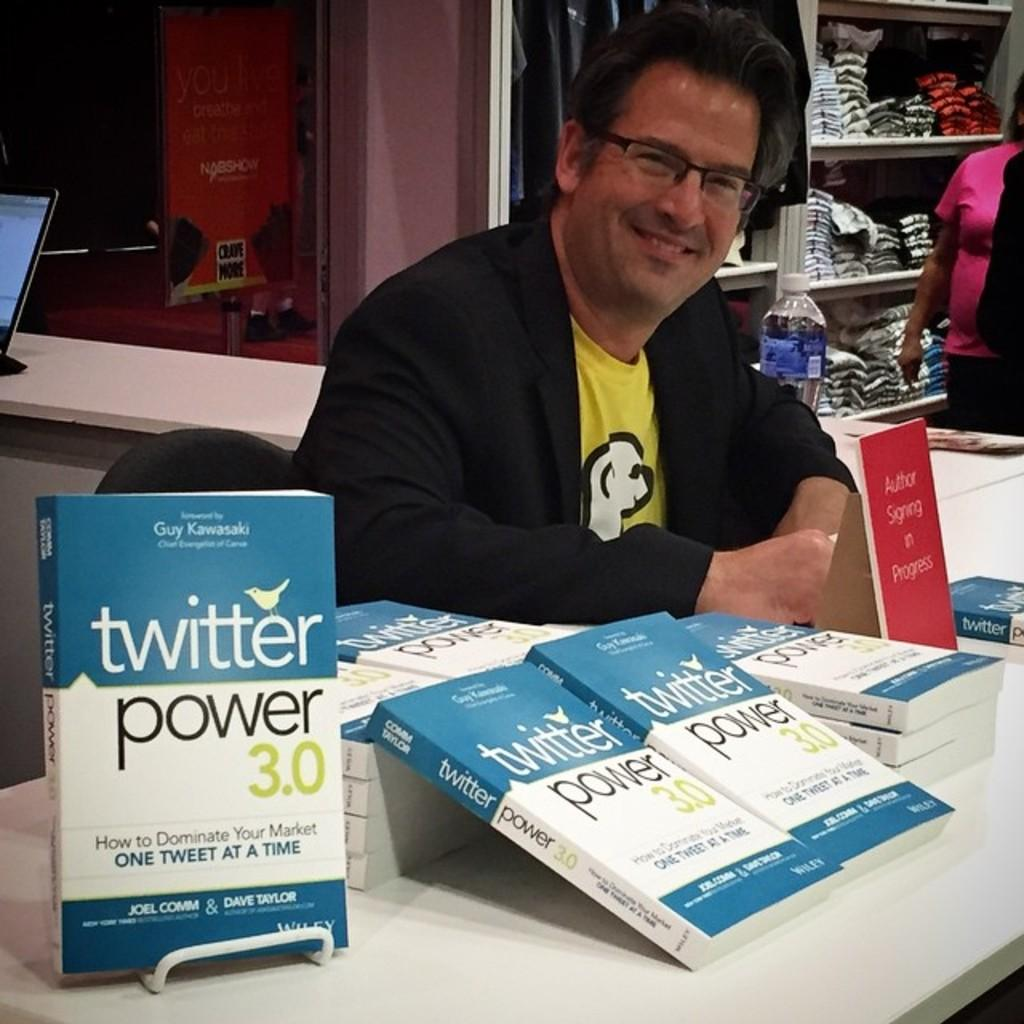Provide a one-sentence caption for the provided image. The author of the book "Twitter Power 3.0" sign copies of his book at a table. 